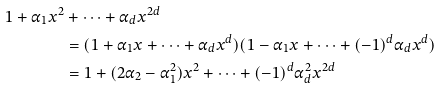<formula> <loc_0><loc_0><loc_500><loc_500>1 + \alpha _ { 1 } x ^ { 2 } & + \cdots + \alpha _ { d } x ^ { 2 d } \\ & = ( 1 + \alpha _ { 1 } x + \cdots + \alpha _ { d } x ^ { d } ) ( 1 - \alpha _ { 1 } x + \cdots + ( - 1 ) ^ { d } \alpha _ { d } x ^ { d } ) \\ & = 1 + ( 2 \alpha _ { 2 } - \alpha _ { 1 } ^ { 2 } ) x ^ { 2 } + \cdots + ( - 1 ) ^ { d } \alpha _ { d } ^ { 2 } x ^ { 2 d }</formula> 